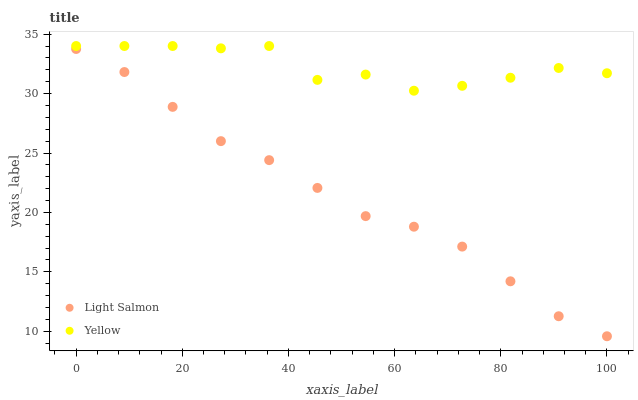Does Light Salmon have the minimum area under the curve?
Answer yes or no. Yes. Does Yellow have the maximum area under the curve?
Answer yes or no. Yes. Does Yellow have the minimum area under the curve?
Answer yes or no. No. Is Light Salmon the smoothest?
Answer yes or no. Yes. Is Yellow the roughest?
Answer yes or no. Yes. Is Yellow the smoothest?
Answer yes or no. No. Does Light Salmon have the lowest value?
Answer yes or no. Yes. Does Yellow have the lowest value?
Answer yes or no. No. Does Yellow have the highest value?
Answer yes or no. Yes. Is Light Salmon less than Yellow?
Answer yes or no. Yes. Is Yellow greater than Light Salmon?
Answer yes or no. Yes. Does Light Salmon intersect Yellow?
Answer yes or no. No. 